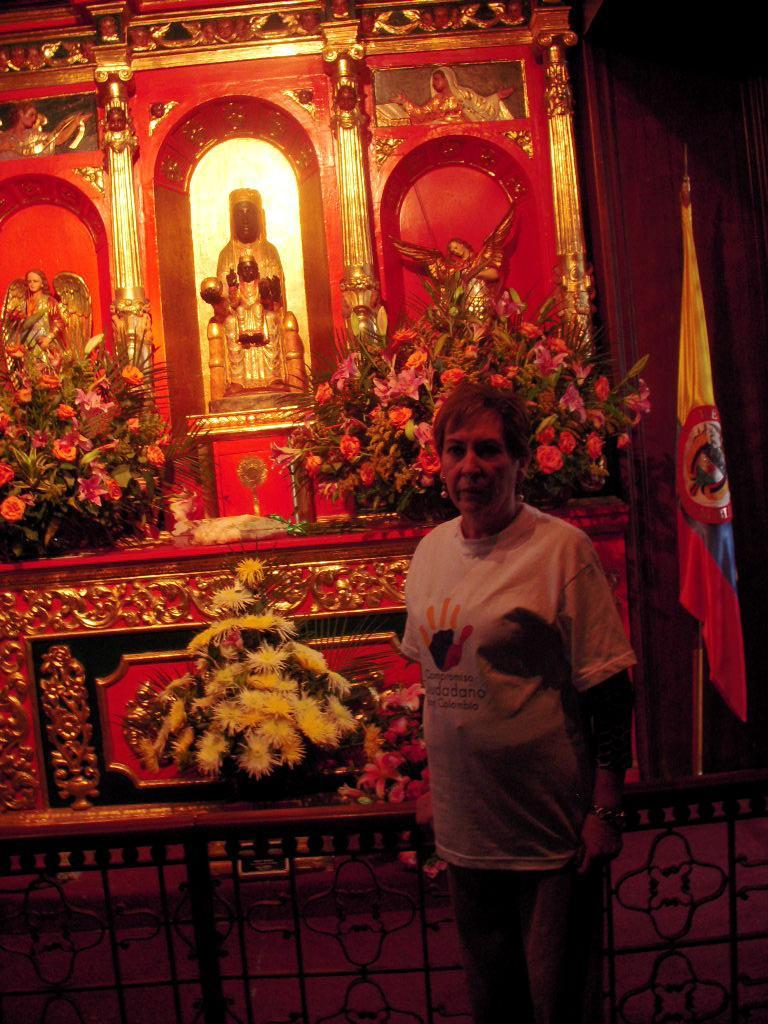What is the main subject of the image? The main subject of the image is a person standing near a fence. What can be seen in the background of the image? In the background of the image, there are statues and flower bouquets. What type of adjustment is being made to the title of the image? There is no title present in the image, so no adjustment can be made. 